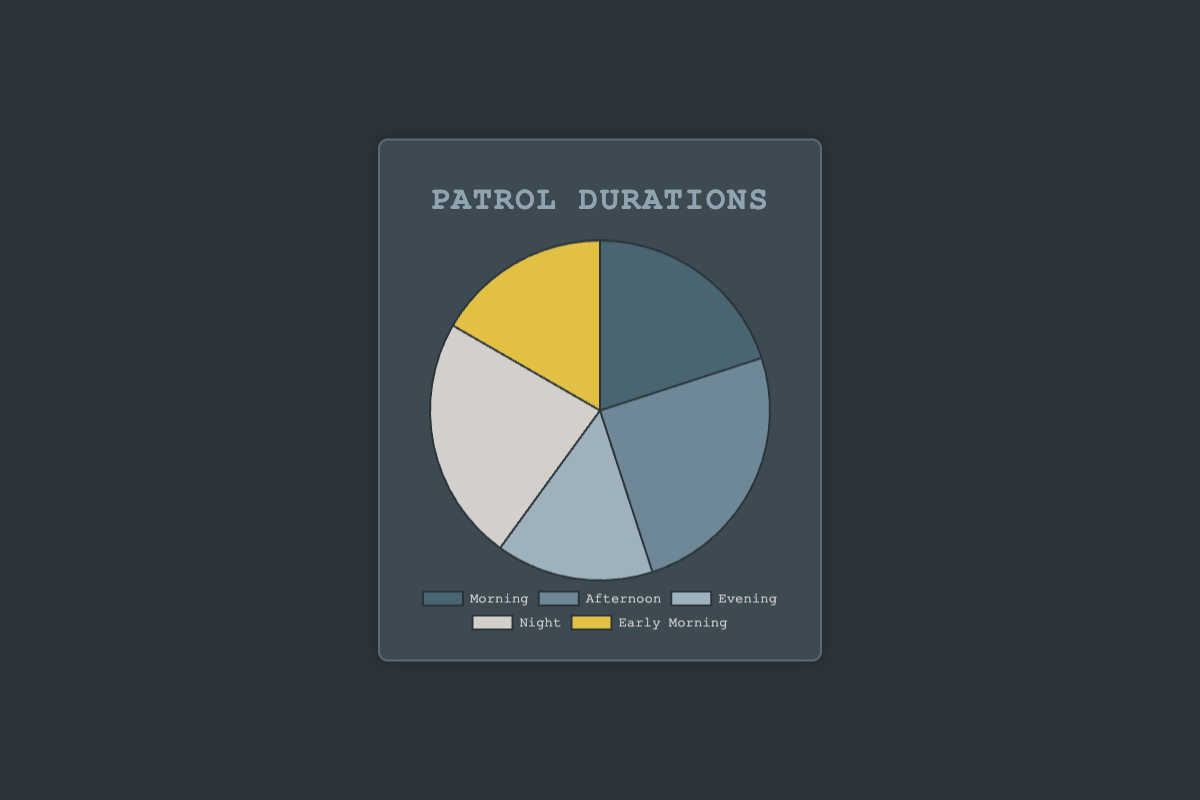What's the total number of hours spent on patrol during the week? To find the total number of hours, add up the hours from all time periods: Morning (12) + Afternoon (15) + Evening (9) + Night (14) + Early Morning (10) = 60 hours
Answer: 60 Which time period has the smallest number of patrol hours? By comparing the hours from each period, Evening has the fewest at 9 hours.
Answer: Evening What's the difference in patrol hours between the Afternoon and Night periods? Subtract the hours for Night (14) from Afternoon (15): 15 - 14 = 1 hour
Answer: 1 What is the combined number of patrol hours for Evening and Night? Add the hours from Evening (9) and Night (14): 9 + 14 = 23 hours
Answer: 23 Which time period has the highest number of patrol hours? By comparing the hours for each period, Afternoon has the most at 15 hours.
Answer: Afternoon How many more patrol hours are there in the Morning compared to Early Morning? Subtract Early Morning (10) from Morning (12): 12 - 10 = 2 hours
Answer: 2 What's the average number of patrol hours across all time periods? Divide the total number of hours (60) by the number of time periods (5): 60 / 5 = 12 hours
Answer: 12 Are the total patrol hours for Night and Early Morning greater than those for Morning and Afternoon? Add Night (14) and Early Morning (10) to get 24, and Morning (12) and Afternoon (15) to get 27. Compare 24 and 27: 24 < 27, so Night and Early Morning are not greater.
Answer: No What is the proportion of patrol hours during the Afternoon compared to the entire week? Divide the Afternoon hours (15) by the total hours (60) and multiply by 100 to get the percentage: (15 / 60) * 100 = 25%
Answer: 25% What color represents the Night period in the pie chart? By referring to the color scheme of the pie chart, Night is represented by a light shade of grey.
Answer: Light grey 